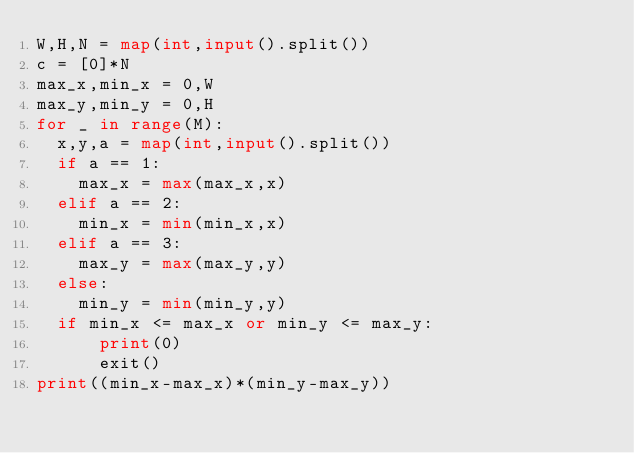Convert code to text. <code><loc_0><loc_0><loc_500><loc_500><_Python_>W,H,N = map(int,input().split())
c = [0]*N
max_x,min_x = 0,W
max_y,min_y = 0,H
for _ in range(M):
  x,y,a = map(int,input().split())
  if a == 1:
    max_x = max(max_x,x)
  elif a == 2:
    min_x = min(min_x,x)
  elif a == 3:
    max_y = max(max_y,y)
  else:
    min_y = min(min_y,y)
  if min_x <= max_x or min_y <= max_y:
      print(0)
      exit()
print((min_x-max_x)*(min_y-max_y))
</code> 